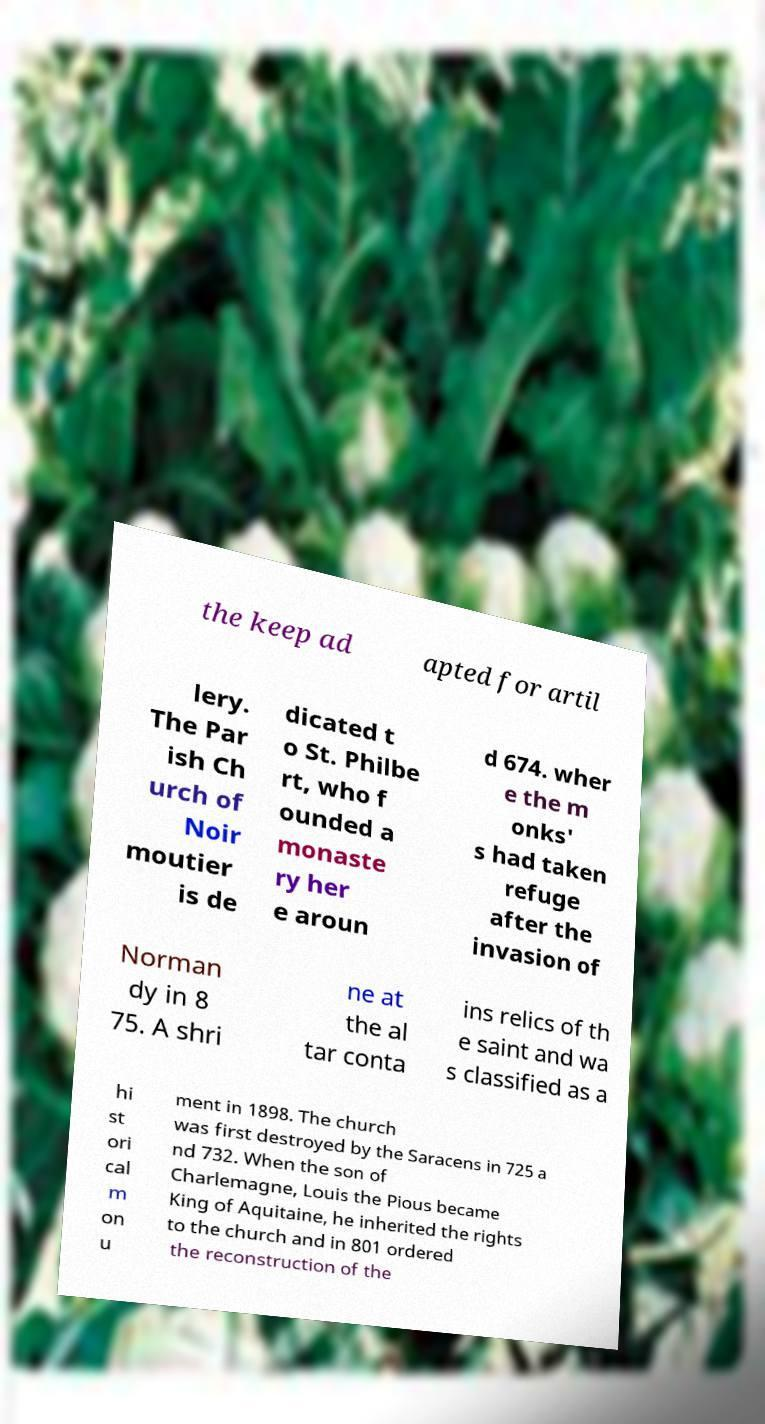Can you read and provide the text displayed in the image?This photo seems to have some interesting text. Can you extract and type it out for me? the keep ad apted for artil lery. The Par ish Ch urch of Noir moutier is de dicated t o St. Philbe rt, who f ounded a monaste ry her e aroun d 674. wher e the m onks' s had taken refuge after the invasion of Norman dy in 8 75. A shri ne at the al tar conta ins relics of th e saint and wa s classified as a hi st ori cal m on u ment in 1898. The church was first destroyed by the Saracens in 725 a nd 732. When the son of Charlemagne, Louis the Pious became King of Aquitaine, he inherited the rights to the church and in 801 ordered the reconstruction of the 